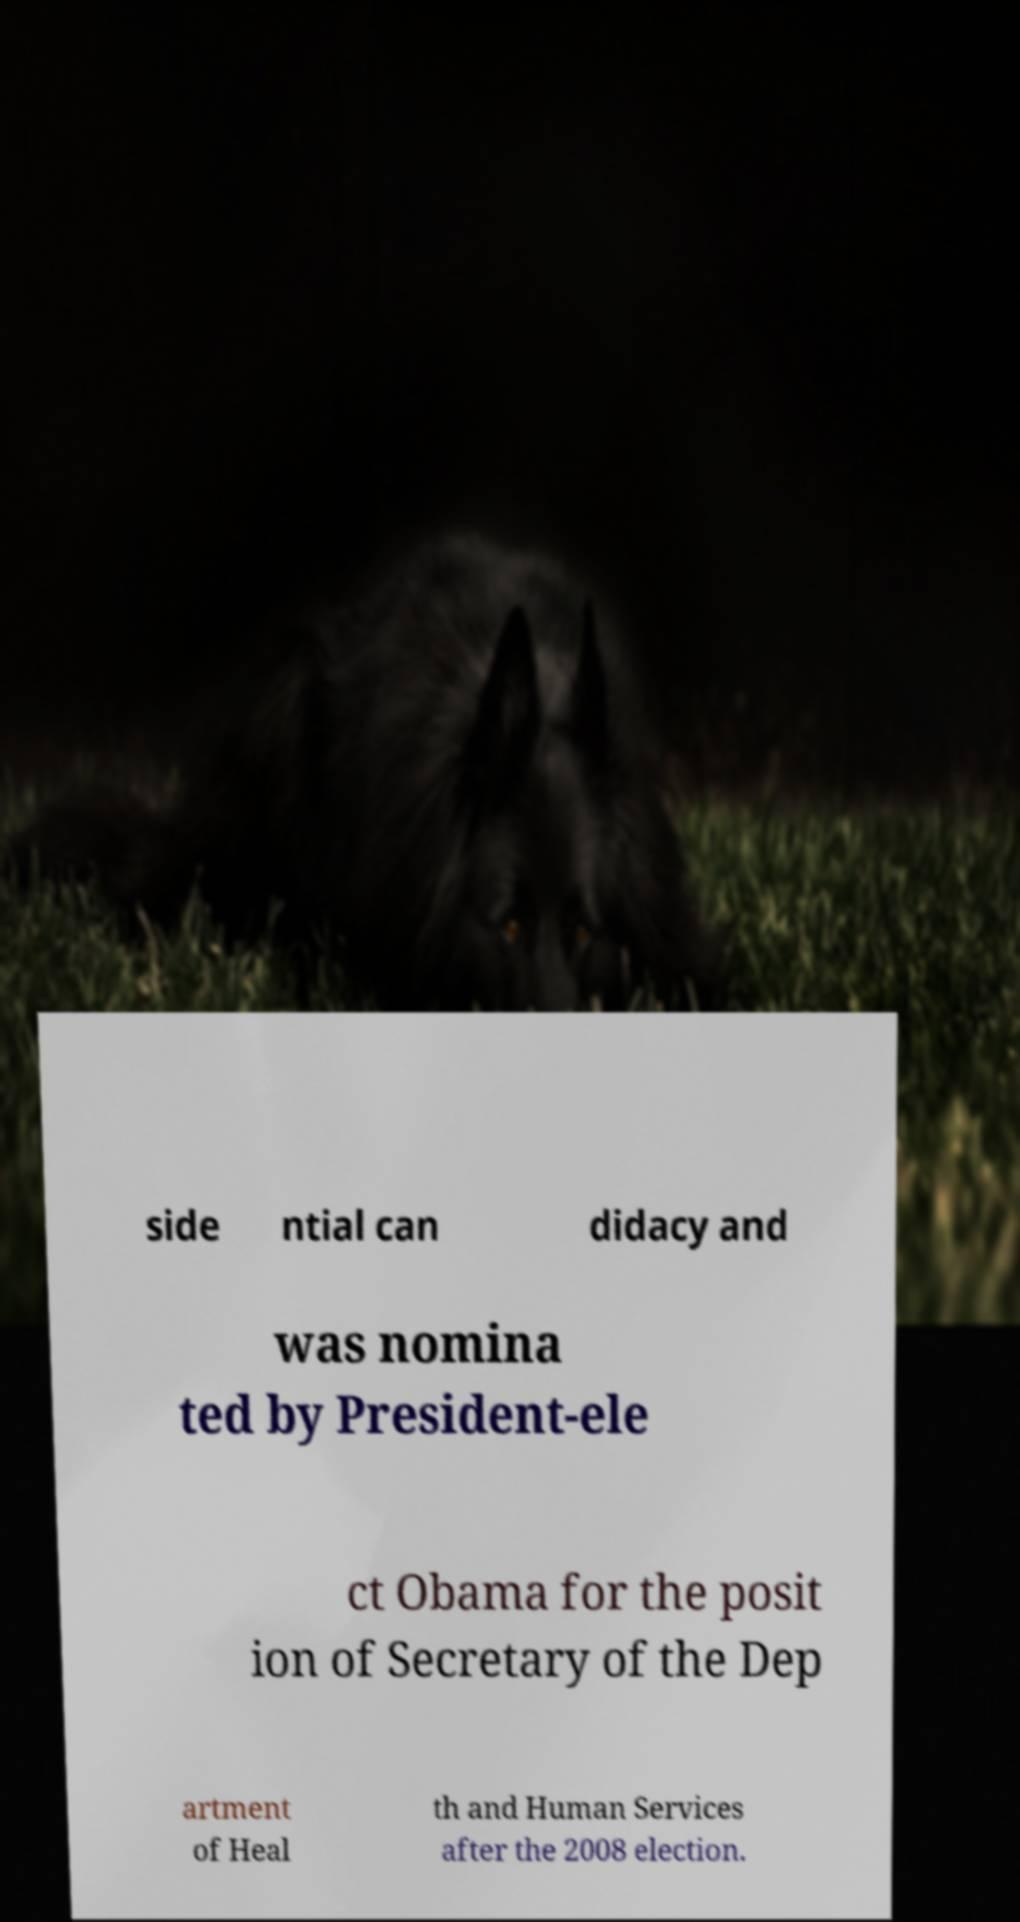Can you read and provide the text displayed in the image?This photo seems to have some interesting text. Can you extract and type it out for me? side ntial can didacy and was nomina ted by President-ele ct Obama for the posit ion of Secretary of the Dep artment of Heal th and Human Services after the 2008 election. 